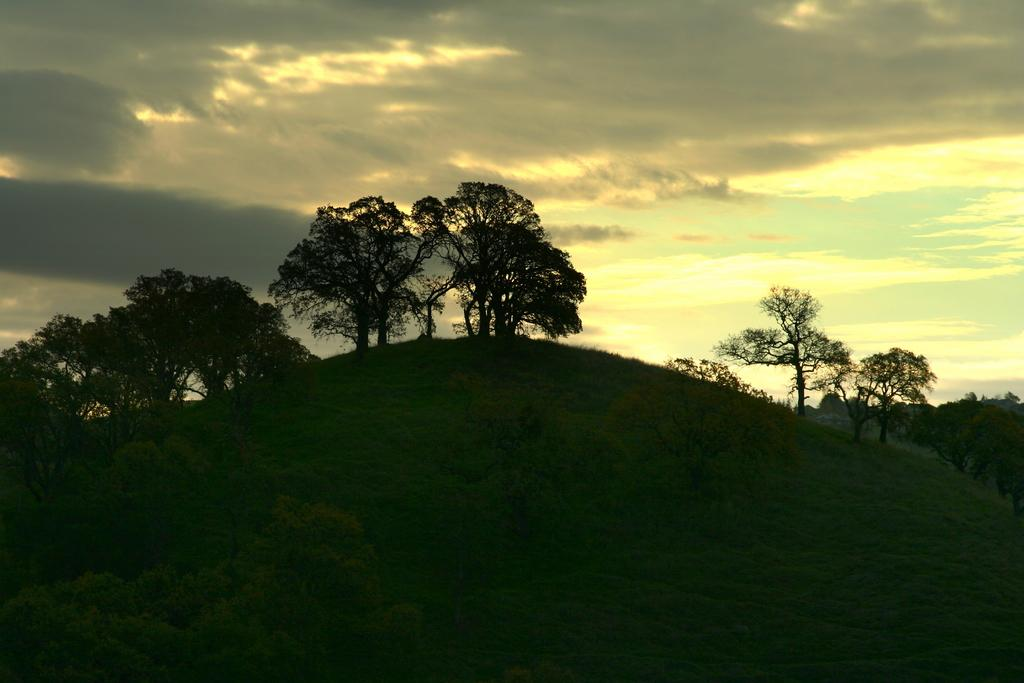What type of landform is visible in the image? There is a hill in the image. What can be seen on the hill? There are trees on the hill. What type of vegetation is at the bottom of the image? There is grass at the bottom of the image. What is visible at the top of the image? The sky is visible at the top of the image. What can be observed in the sky? Clouds are present in the sky. Where is the curtain located in the image? There is no curtain present in the image. What type of bottle can be seen on the hill? There is no bottle visible on the hill in the image. 